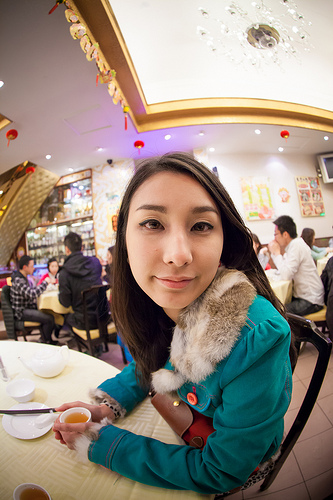<image>
Can you confirm if the light is above the man? Yes. The light is positioned above the man in the vertical space, higher up in the scene. 